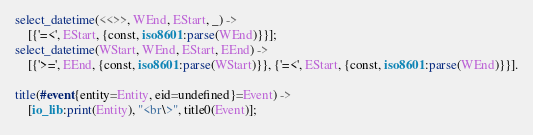Convert code to text. <code><loc_0><loc_0><loc_500><loc_500><_Erlang_>select_datetime(<<>>, WEnd, EStart, _) ->
    [{'=<', EStart, {const, iso8601:parse(WEnd)}}];
select_datetime(WStart, WEnd, EStart, EEnd) ->
    [{'>=', EEnd, {const, iso8601:parse(WStart)}}, {'=<', EStart, {const, iso8601:parse(WEnd)}}].

title(#event{entity=Entity, eid=undefined}=Event) ->
    [io_lib:print(Entity), "<br\>", title0(Event)];</code> 